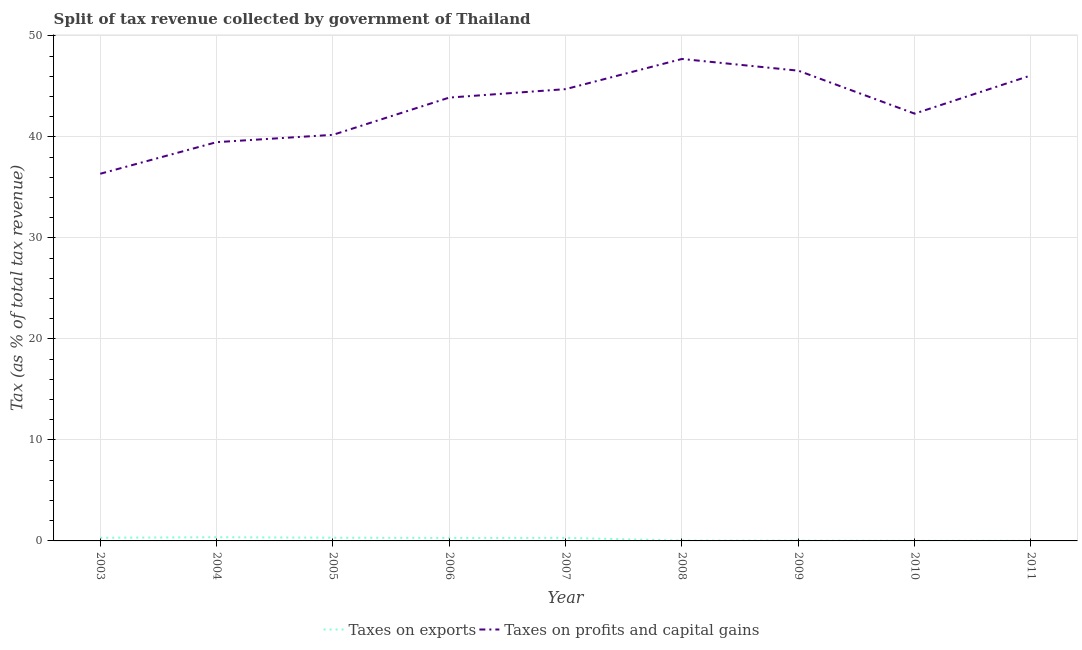Is the number of lines equal to the number of legend labels?
Provide a succinct answer. Yes. What is the percentage of revenue obtained from taxes on profits and capital gains in 2008?
Ensure brevity in your answer.  47.72. Across all years, what is the maximum percentage of revenue obtained from taxes on profits and capital gains?
Offer a terse response. 47.72. Across all years, what is the minimum percentage of revenue obtained from taxes on exports?
Offer a terse response. 0.01. In which year was the percentage of revenue obtained from taxes on exports maximum?
Give a very brief answer. 2004. In which year was the percentage of revenue obtained from taxes on profits and capital gains minimum?
Provide a succinct answer. 2003. What is the total percentage of revenue obtained from taxes on profits and capital gains in the graph?
Your response must be concise. 387.38. What is the difference between the percentage of revenue obtained from taxes on profits and capital gains in 2007 and that in 2010?
Ensure brevity in your answer.  2.43. What is the difference between the percentage of revenue obtained from taxes on exports in 2006 and the percentage of revenue obtained from taxes on profits and capital gains in 2011?
Provide a succinct answer. -45.8. What is the average percentage of revenue obtained from taxes on exports per year?
Your answer should be very brief. 0.19. In the year 2006, what is the difference between the percentage of revenue obtained from taxes on exports and percentage of revenue obtained from taxes on profits and capital gains?
Keep it short and to the point. -43.6. In how many years, is the percentage of revenue obtained from taxes on exports greater than 30 %?
Offer a very short reply. 0. What is the ratio of the percentage of revenue obtained from taxes on profits and capital gains in 2005 to that in 2008?
Offer a very short reply. 0.84. Is the percentage of revenue obtained from taxes on profits and capital gains in 2006 less than that in 2009?
Your response must be concise. Yes. Is the difference between the percentage of revenue obtained from taxes on profits and capital gains in 2006 and 2008 greater than the difference between the percentage of revenue obtained from taxes on exports in 2006 and 2008?
Provide a short and direct response. No. What is the difference between the highest and the second highest percentage of revenue obtained from taxes on exports?
Make the answer very short. 0.05. What is the difference between the highest and the lowest percentage of revenue obtained from taxes on profits and capital gains?
Provide a succinct answer. 11.37. Is the sum of the percentage of revenue obtained from taxes on exports in 2004 and 2005 greater than the maximum percentage of revenue obtained from taxes on profits and capital gains across all years?
Ensure brevity in your answer.  No. Is the percentage of revenue obtained from taxes on exports strictly less than the percentage of revenue obtained from taxes on profits and capital gains over the years?
Keep it short and to the point. Yes. How many lines are there?
Make the answer very short. 2. How many years are there in the graph?
Provide a short and direct response. 9. What is the difference between two consecutive major ticks on the Y-axis?
Make the answer very short. 10. Does the graph contain any zero values?
Make the answer very short. No. Does the graph contain grids?
Offer a terse response. Yes. Where does the legend appear in the graph?
Keep it short and to the point. Bottom center. What is the title of the graph?
Your response must be concise. Split of tax revenue collected by government of Thailand. Does "DAC donors" appear as one of the legend labels in the graph?
Offer a very short reply. No. What is the label or title of the X-axis?
Your response must be concise. Year. What is the label or title of the Y-axis?
Make the answer very short. Tax (as % of total tax revenue). What is the Tax (as % of total tax revenue) of Taxes on exports in 2003?
Keep it short and to the point. 0.31. What is the Tax (as % of total tax revenue) of Taxes on profits and capital gains in 2003?
Make the answer very short. 36.36. What is the Tax (as % of total tax revenue) of Taxes on exports in 2004?
Ensure brevity in your answer.  0.37. What is the Tax (as % of total tax revenue) in Taxes on profits and capital gains in 2004?
Provide a short and direct response. 39.49. What is the Tax (as % of total tax revenue) in Taxes on exports in 2005?
Provide a short and direct response. 0.32. What is the Tax (as % of total tax revenue) of Taxes on profits and capital gains in 2005?
Keep it short and to the point. 40.21. What is the Tax (as % of total tax revenue) in Taxes on exports in 2006?
Offer a very short reply. 0.3. What is the Tax (as % of total tax revenue) in Taxes on profits and capital gains in 2006?
Your answer should be compact. 43.9. What is the Tax (as % of total tax revenue) in Taxes on exports in 2007?
Provide a succinct answer. 0.3. What is the Tax (as % of total tax revenue) in Taxes on profits and capital gains in 2007?
Your answer should be very brief. 44.74. What is the Tax (as % of total tax revenue) of Taxes on exports in 2008?
Ensure brevity in your answer.  0.03. What is the Tax (as % of total tax revenue) in Taxes on profits and capital gains in 2008?
Offer a terse response. 47.72. What is the Tax (as % of total tax revenue) of Taxes on exports in 2009?
Provide a succinct answer. 0.03. What is the Tax (as % of total tax revenue) of Taxes on profits and capital gains in 2009?
Offer a terse response. 46.57. What is the Tax (as % of total tax revenue) in Taxes on exports in 2010?
Ensure brevity in your answer.  0.01. What is the Tax (as % of total tax revenue) of Taxes on profits and capital gains in 2010?
Provide a short and direct response. 42.31. What is the Tax (as % of total tax revenue) in Taxes on exports in 2011?
Make the answer very short. 0.01. What is the Tax (as % of total tax revenue) of Taxes on profits and capital gains in 2011?
Provide a succinct answer. 46.09. Across all years, what is the maximum Tax (as % of total tax revenue) of Taxes on exports?
Give a very brief answer. 0.37. Across all years, what is the maximum Tax (as % of total tax revenue) in Taxes on profits and capital gains?
Provide a succinct answer. 47.72. Across all years, what is the minimum Tax (as % of total tax revenue) in Taxes on exports?
Offer a terse response. 0.01. Across all years, what is the minimum Tax (as % of total tax revenue) of Taxes on profits and capital gains?
Give a very brief answer. 36.36. What is the total Tax (as % of total tax revenue) of Taxes on exports in the graph?
Provide a succinct answer. 1.68. What is the total Tax (as % of total tax revenue) in Taxes on profits and capital gains in the graph?
Make the answer very short. 387.38. What is the difference between the Tax (as % of total tax revenue) of Taxes on exports in 2003 and that in 2004?
Offer a very short reply. -0.05. What is the difference between the Tax (as % of total tax revenue) in Taxes on profits and capital gains in 2003 and that in 2004?
Offer a terse response. -3.13. What is the difference between the Tax (as % of total tax revenue) in Taxes on exports in 2003 and that in 2005?
Provide a short and direct response. -0. What is the difference between the Tax (as % of total tax revenue) in Taxes on profits and capital gains in 2003 and that in 2005?
Offer a very short reply. -3.86. What is the difference between the Tax (as % of total tax revenue) in Taxes on exports in 2003 and that in 2006?
Give a very brief answer. 0.02. What is the difference between the Tax (as % of total tax revenue) of Taxes on profits and capital gains in 2003 and that in 2006?
Provide a short and direct response. -7.54. What is the difference between the Tax (as % of total tax revenue) of Taxes on exports in 2003 and that in 2007?
Your answer should be compact. 0.01. What is the difference between the Tax (as % of total tax revenue) of Taxes on profits and capital gains in 2003 and that in 2007?
Keep it short and to the point. -8.38. What is the difference between the Tax (as % of total tax revenue) in Taxes on exports in 2003 and that in 2008?
Provide a short and direct response. 0.28. What is the difference between the Tax (as % of total tax revenue) of Taxes on profits and capital gains in 2003 and that in 2008?
Provide a succinct answer. -11.37. What is the difference between the Tax (as % of total tax revenue) of Taxes on exports in 2003 and that in 2009?
Provide a succinct answer. 0.28. What is the difference between the Tax (as % of total tax revenue) in Taxes on profits and capital gains in 2003 and that in 2009?
Give a very brief answer. -10.21. What is the difference between the Tax (as % of total tax revenue) of Taxes on exports in 2003 and that in 2010?
Make the answer very short. 0.3. What is the difference between the Tax (as % of total tax revenue) of Taxes on profits and capital gains in 2003 and that in 2010?
Provide a succinct answer. -5.95. What is the difference between the Tax (as % of total tax revenue) in Taxes on exports in 2003 and that in 2011?
Your response must be concise. 0.3. What is the difference between the Tax (as % of total tax revenue) of Taxes on profits and capital gains in 2003 and that in 2011?
Provide a succinct answer. -9.74. What is the difference between the Tax (as % of total tax revenue) in Taxes on exports in 2004 and that in 2005?
Give a very brief answer. 0.05. What is the difference between the Tax (as % of total tax revenue) of Taxes on profits and capital gains in 2004 and that in 2005?
Your answer should be compact. -0.73. What is the difference between the Tax (as % of total tax revenue) in Taxes on exports in 2004 and that in 2006?
Give a very brief answer. 0.07. What is the difference between the Tax (as % of total tax revenue) of Taxes on profits and capital gains in 2004 and that in 2006?
Your answer should be very brief. -4.41. What is the difference between the Tax (as % of total tax revenue) in Taxes on exports in 2004 and that in 2007?
Give a very brief answer. 0.06. What is the difference between the Tax (as % of total tax revenue) of Taxes on profits and capital gains in 2004 and that in 2007?
Your answer should be very brief. -5.25. What is the difference between the Tax (as % of total tax revenue) of Taxes on exports in 2004 and that in 2008?
Provide a succinct answer. 0.33. What is the difference between the Tax (as % of total tax revenue) in Taxes on profits and capital gains in 2004 and that in 2008?
Ensure brevity in your answer.  -8.24. What is the difference between the Tax (as % of total tax revenue) in Taxes on exports in 2004 and that in 2009?
Keep it short and to the point. 0.34. What is the difference between the Tax (as % of total tax revenue) of Taxes on profits and capital gains in 2004 and that in 2009?
Ensure brevity in your answer.  -7.08. What is the difference between the Tax (as % of total tax revenue) in Taxes on exports in 2004 and that in 2010?
Your answer should be compact. 0.36. What is the difference between the Tax (as % of total tax revenue) of Taxes on profits and capital gains in 2004 and that in 2010?
Give a very brief answer. -2.82. What is the difference between the Tax (as % of total tax revenue) in Taxes on exports in 2004 and that in 2011?
Your answer should be compact. 0.35. What is the difference between the Tax (as % of total tax revenue) in Taxes on profits and capital gains in 2004 and that in 2011?
Offer a very short reply. -6.61. What is the difference between the Tax (as % of total tax revenue) of Taxes on exports in 2005 and that in 2006?
Your response must be concise. 0.02. What is the difference between the Tax (as % of total tax revenue) of Taxes on profits and capital gains in 2005 and that in 2006?
Make the answer very short. -3.69. What is the difference between the Tax (as % of total tax revenue) of Taxes on exports in 2005 and that in 2007?
Provide a short and direct response. 0.01. What is the difference between the Tax (as % of total tax revenue) of Taxes on profits and capital gains in 2005 and that in 2007?
Keep it short and to the point. -4.53. What is the difference between the Tax (as % of total tax revenue) of Taxes on exports in 2005 and that in 2008?
Your response must be concise. 0.28. What is the difference between the Tax (as % of total tax revenue) in Taxes on profits and capital gains in 2005 and that in 2008?
Your answer should be very brief. -7.51. What is the difference between the Tax (as % of total tax revenue) in Taxes on exports in 2005 and that in 2009?
Make the answer very short. 0.29. What is the difference between the Tax (as % of total tax revenue) of Taxes on profits and capital gains in 2005 and that in 2009?
Give a very brief answer. -6.35. What is the difference between the Tax (as % of total tax revenue) of Taxes on exports in 2005 and that in 2010?
Your answer should be compact. 0.31. What is the difference between the Tax (as % of total tax revenue) in Taxes on profits and capital gains in 2005 and that in 2010?
Keep it short and to the point. -2.1. What is the difference between the Tax (as % of total tax revenue) in Taxes on exports in 2005 and that in 2011?
Offer a very short reply. 0.3. What is the difference between the Tax (as % of total tax revenue) of Taxes on profits and capital gains in 2005 and that in 2011?
Your response must be concise. -5.88. What is the difference between the Tax (as % of total tax revenue) of Taxes on exports in 2006 and that in 2007?
Provide a short and direct response. -0.01. What is the difference between the Tax (as % of total tax revenue) of Taxes on profits and capital gains in 2006 and that in 2007?
Give a very brief answer. -0.84. What is the difference between the Tax (as % of total tax revenue) in Taxes on exports in 2006 and that in 2008?
Make the answer very short. 0.26. What is the difference between the Tax (as % of total tax revenue) of Taxes on profits and capital gains in 2006 and that in 2008?
Offer a very short reply. -3.82. What is the difference between the Tax (as % of total tax revenue) of Taxes on exports in 2006 and that in 2009?
Keep it short and to the point. 0.27. What is the difference between the Tax (as % of total tax revenue) of Taxes on profits and capital gains in 2006 and that in 2009?
Your answer should be compact. -2.67. What is the difference between the Tax (as % of total tax revenue) of Taxes on exports in 2006 and that in 2010?
Offer a very short reply. 0.28. What is the difference between the Tax (as % of total tax revenue) of Taxes on profits and capital gains in 2006 and that in 2010?
Ensure brevity in your answer.  1.59. What is the difference between the Tax (as % of total tax revenue) in Taxes on exports in 2006 and that in 2011?
Offer a very short reply. 0.28. What is the difference between the Tax (as % of total tax revenue) of Taxes on profits and capital gains in 2006 and that in 2011?
Keep it short and to the point. -2.19. What is the difference between the Tax (as % of total tax revenue) of Taxes on exports in 2007 and that in 2008?
Your answer should be very brief. 0.27. What is the difference between the Tax (as % of total tax revenue) in Taxes on profits and capital gains in 2007 and that in 2008?
Give a very brief answer. -2.99. What is the difference between the Tax (as % of total tax revenue) of Taxes on exports in 2007 and that in 2009?
Ensure brevity in your answer.  0.27. What is the difference between the Tax (as % of total tax revenue) in Taxes on profits and capital gains in 2007 and that in 2009?
Ensure brevity in your answer.  -1.83. What is the difference between the Tax (as % of total tax revenue) in Taxes on exports in 2007 and that in 2010?
Ensure brevity in your answer.  0.29. What is the difference between the Tax (as % of total tax revenue) of Taxes on profits and capital gains in 2007 and that in 2010?
Your response must be concise. 2.43. What is the difference between the Tax (as % of total tax revenue) in Taxes on exports in 2007 and that in 2011?
Your response must be concise. 0.29. What is the difference between the Tax (as % of total tax revenue) of Taxes on profits and capital gains in 2007 and that in 2011?
Your answer should be compact. -1.36. What is the difference between the Tax (as % of total tax revenue) of Taxes on exports in 2008 and that in 2009?
Make the answer very short. 0. What is the difference between the Tax (as % of total tax revenue) of Taxes on profits and capital gains in 2008 and that in 2009?
Your answer should be very brief. 1.16. What is the difference between the Tax (as % of total tax revenue) of Taxes on exports in 2008 and that in 2010?
Your answer should be compact. 0.02. What is the difference between the Tax (as % of total tax revenue) in Taxes on profits and capital gains in 2008 and that in 2010?
Provide a succinct answer. 5.41. What is the difference between the Tax (as % of total tax revenue) in Taxes on exports in 2008 and that in 2011?
Your answer should be very brief. 0.02. What is the difference between the Tax (as % of total tax revenue) in Taxes on profits and capital gains in 2008 and that in 2011?
Provide a short and direct response. 1.63. What is the difference between the Tax (as % of total tax revenue) in Taxes on exports in 2009 and that in 2010?
Offer a terse response. 0.02. What is the difference between the Tax (as % of total tax revenue) in Taxes on profits and capital gains in 2009 and that in 2010?
Ensure brevity in your answer.  4.26. What is the difference between the Tax (as % of total tax revenue) in Taxes on exports in 2009 and that in 2011?
Give a very brief answer. 0.02. What is the difference between the Tax (as % of total tax revenue) in Taxes on profits and capital gains in 2009 and that in 2011?
Give a very brief answer. 0.47. What is the difference between the Tax (as % of total tax revenue) of Taxes on exports in 2010 and that in 2011?
Keep it short and to the point. -0. What is the difference between the Tax (as % of total tax revenue) in Taxes on profits and capital gains in 2010 and that in 2011?
Your answer should be very brief. -3.78. What is the difference between the Tax (as % of total tax revenue) in Taxes on exports in 2003 and the Tax (as % of total tax revenue) in Taxes on profits and capital gains in 2004?
Ensure brevity in your answer.  -39.17. What is the difference between the Tax (as % of total tax revenue) in Taxes on exports in 2003 and the Tax (as % of total tax revenue) in Taxes on profits and capital gains in 2005?
Give a very brief answer. -39.9. What is the difference between the Tax (as % of total tax revenue) in Taxes on exports in 2003 and the Tax (as % of total tax revenue) in Taxes on profits and capital gains in 2006?
Your answer should be compact. -43.59. What is the difference between the Tax (as % of total tax revenue) in Taxes on exports in 2003 and the Tax (as % of total tax revenue) in Taxes on profits and capital gains in 2007?
Offer a very short reply. -44.42. What is the difference between the Tax (as % of total tax revenue) of Taxes on exports in 2003 and the Tax (as % of total tax revenue) of Taxes on profits and capital gains in 2008?
Offer a very short reply. -47.41. What is the difference between the Tax (as % of total tax revenue) in Taxes on exports in 2003 and the Tax (as % of total tax revenue) in Taxes on profits and capital gains in 2009?
Ensure brevity in your answer.  -46.25. What is the difference between the Tax (as % of total tax revenue) of Taxes on exports in 2003 and the Tax (as % of total tax revenue) of Taxes on profits and capital gains in 2010?
Provide a short and direct response. -42. What is the difference between the Tax (as % of total tax revenue) in Taxes on exports in 2003 and the Tax (as % of total tax revenue) in Taxes on profits and capital gains in 2011?
Offer a terse response. -45.78. What is the difference between the Tax (as % of total tax revenue) in Taxes on exports in 2004 and the Tax (as % of total tax revenue) in Taxes on profits and capital gains in 2005?
Make the answer very short. -39.85. What is the difference between the Tax (as % of total tax revenue) of Taxes on exports in 2004 and the Tax (as % of total tax revenue) of Taxes on profits and capital gains in 2006?
Give a very brief answer. -43.53. What is the difference between the Tax (as % of total tax revenue) in Taxes on exports in 2004 and the Tax (as % of total tax revenue) in Taxes on profits and capital gains in 2007?
Give a very brief answer. -44.37. What is the difference between the Tax (as % of total tax revenue) of Taxes on exports in 2004 and the Tax (as % of total tax revenue) of Taxes on profits and capital gains in 2008?
Your answer should be very brief. -47.36. What is the difference between the Tax (as % of total tax revenue) in Taxes on exports in 2004 and the Tax (as % of total tax revenue) in Taxes on profits and capital gains in 2009?
Your answer should be compact. -46.2. What is the difference between the Tax (as % of total tax revenue) in Taxes on exports in 2004 and the Tax (as % of total tax revenue) in Taxes on profits and capital gains in 2010?
Provide a short and direct response. -41.94. What is the difference between the Tax (as % of total tax revenue) of Taxes on exports in 2004 and the Tax (as % of total tax revenue) of Taxes on profits and capital gains in 2011?
Offer a terse response. -45.73. What is the difference between the Tax (as % of total tax revenue) of Taxes on exports in 2005 and the Tax (as % of total tax revenue) of Taxes on profits and capital gains in 2006?
Offer a very short reply. -43.58. What is the difference between the Tax (as % of total tax revenue) in Taxes on exports in 2005 and the Tax (as % of total tax revenue) in Taxes on profits and capital gains in 2007?
Make the answer very short. -44.42. What is the difference between the Tax (as % of total tax revenue) in Taxes on exports in 2005 and the Tax (as % of total tax revenue) in Taxes on profits and capital gains in 2008?
Ensure brevity in your answer.  -47.41. What is the difference between the Tax (as % of total tax revenue) of Taxes on exports in 2005 and the Tax (as % of total tax revenue) of Taxes on profits and capital gains in 2009?
Make the answer very short. -46.25. What is the difference between the Tax (as % of total tax revenue) in Taxes on exports in 2005 and the Tax (as % of total tax revenue) in Taxes on profits and capital gains in 2010?
Ensure brevity in your answer.  -41.99. What is the difference between the Tax (as % of total tax revenue) of Taxes on exports in 2005 and the Tax (as % of total tax revenue) of Taxes on profits and capital gains in 2011?
Your response must be concise. -45.78. What is the difference between the Tax (as % of total tax revenue) in Taxes on exports in 2006 and the Tax (as % of total tax revenue) in Taxes on profits and capital gains in 2007?
Provide a short and direct response. -44.44. What is the difference between the Tax (as % of total tax revenue) of Taxes on exports in 2006 and the Tax (as % of total tax revenue) of Taxes on profits and capital gains in 2008?
Your answer should be very brief. -47.43. What is the difference between the Tax (as % of total tax revenue) of Taxes on exports in 2006 and the Tax (as % of total tax revenue) of Taxes on profits and capital gains in 2009?
Keep it short and to the point. -46.27. What is the difference between the Tax (as % of total tax revenue) in Taxes on exports in 2006 and the Tax (as % of total tax revenue) in Taxes on profits and capital gains in 2010?
Provide a succinct answer. -42.01. What is the difference between the Tax (as % of total tax revenue) in Taxes on exports in 2006 and the Tax (as % of total tax revenue) in Taxes on profits and capital gains in 2011?
Your answer should be very brief. -45.8. What is the difference between the Tax (as % of total tax revenue) in Taxes on exports in 2007 and the Tax (as % of total tax revenue) in Taxes on profits and capital gains in 2008?
Offer a terse response. -47.42. What is the difference between the Tax (as % of total tax revenue) in Taxes on exports in 2007 and the Tax (as % of total tax revenue) in Taxes on profits and capital gains in 2009?
Your response must be concise. -46.26. What is the difference between the Tax (as % of total tax revenue) of Taxes on exports in 2007 and the Tax (as % of total tax revenue) of Taxes on profits and capital gains in 2010?
Your answer should be very brief. -42.01. What is the difference between the Tax (as % of total tax revenue) of Taxes on exports in 2007 and the Tax (as % of total tax revenue) of Taxes on profits and capital gains in 2011?
Your response must be concise. -45.79. What is the difference between the Tax (as % of total tax revenue) of Taxes on exports in 2008 and the Tax (as % of total tax revenue) of Taxes on profits and capital gains in 2009?
Offer a very short reply. -46.53. What is the difference between the Tax (as % of total tax revenue) of Taxes on exports in 2008 and the Tax (as % of total tax revenue) of Taxes on profits and capital gains in 2010?
Provide a succinct answer. -42.28. What is the difference between the Tax (as % of total tax revenue) of Taxes on exports in 2008 and the Tax (as % of total tax revenue) of Taxes on profits and capital gains in 2011?
Your answer should be compact. -46.06. What is the difference between the Tax (as % of total tax revenue) in Taxes on exports in 2009 and the Tax (as % of total tax revenue) in Taxes on profits and capital gains in 2010?
Ensure brevity in your answer.  -42.28. What is the difference between the Tax (as % of total tax revenue) of Taxes on exports in 2009 and the Tax (as % of total tax revenue) of Taxes on profits and capital gains in 2011?
Provide a short and direct response. -46.06. What is the difference between the Tax (as % of total tax revenue) in Taxes on exports in 2010 and the Tax (as % of total tax revenue) in Taxes on profits and capital gains in 2011?
Offer a very short reply. -46.08. What is the average Tax (as % of total tax revenue) in Taxes on exports per year?
Offer a very short reply. 0.19. What is the average Tax (as % of total tax revenue) of Taxes on profits and capital gains per year?
Your answer should be compact. 43.04. In the year 2003, what is the difference between the Tax (as % of total tax revenue) of Taxes on exports and Tax (as % of total tax revenue) of Taxes on profits and capital gains?
Offer a terse response. -36.04. In the year 2004, what is the difference between the Tax (as % of total tax revenue) in Taxes on exports and Tax (as % of total tax revenue) in Taxes on profits and capital gains?
Your answer should be very brief. -39.12. In the year 2005, what is the difference between the Tax (as % of total tax revenue) in Taxes on exports and Tax (as % of total tax revenue) in Taxes on profits and capital gains?
Your answer should be compact. -39.89. In the year 2006, what is the difference between the Tax (as % of total tax revenue) of Taxes on exports and Tax (as % of total tax revenue) of Taxes on profits and capital gains?
Provide a succinct answer. -43.6. In the year 2007, what is the difference between the Tax (as % of total tax revenue) in Taxes on exports and Tax (as % of total tax revenue) in Taxes on profits and capital gains?
Your answer should be very brief. -44.43. In the year 2008, what is the difference between the Tax (as % of total tax revenue) in Taxes on exports and Tax (as % of total tax revenue) in Taxes on profits and capital gains?
Ensure brevity in your answer.  -47.69. In the year 2009, what is the difference between the Tax (as % of total tax revenue) in Taxes on exports and Tax (as % of total tax revenue) in Taxes on profits and capital gains?
Keep it short and to the point. -46.54. In the year 2010, what is the difference between the Tax (as % of total tax revenue) of Taxes on exports and Tax (as % of total tax revenue) of Taxes on profits and capital gains?
Your answer should be compact. -42.3. In the year 2011, what is the difference between the Tax (as % of total tax revenue) in Taxes on exports and Tax (as % of total tax revenue) in Taxes on profits and capital gains?
Your answer should be compact. -46.08. What is the ratio of the Tax (as % of total tax revenue) in Taxes on exports in 2003 to that in 2004?
Ensure brevity in your answer.  0.85. What is the ratio of the Tax (as % of total tax revenue) of Taxes on profits and capital gains in 2003 to that in 2004?
Give a very brief answer. 0.92. What is the ratio of the Tax (as % of total tax revenue) of Taxes on exports in 2003 to that in 2005?
Ensure brevity in your answer.  0.99. What is the ratio of the Tax (as % of total tax revenue) in Taxes on profits and capital gains in 2003 to that in 2005?
Provide a short and direct response. 0.9. What is the ratio of the Tax (as % of total tax revenue) of Taxes on exports in 2003 to that in 2006?
Keep it short and to the point. 1.06. What is the ratio of the Tax (as % of total tax revenue) of Taxes on profits and capital gains in 2003 to that in 2006?
Offer a very short reply. 0.83. What is the ratio of the Tax (as % of total tax revenue) in Taxes on exports in 2003 to that in 2007?
Offer a very short reply. 1.03. What is the ratio of the Tax (as % of total tax revenue) in Taxes on profits and capital gains in 2003 to that in 2007?
Your answer should be compact. 0.81. What is the ratio of the Tax (as % of total tax revenue) of Taxes on exports in 2003 to that in 2008?
Provide a short and direct response. 9.35. What is the ratio of the Tax (as % of total tax revenue) of Taxes on profits and capital gains in 2003 to that in 2008?
Provide a short and direct response. 0.76. What is the ratio of the Tax (as % of total tax revenue) of Taxes on exports in 2003 to that in 2009?
Your answer should be very brief. 10.73. What is the ratio of the Tax (as % of total tax revenue) in Taxes on profits and capital gains in 2003 to that in 2009?
Make the answer very short. 0.78. What is the ratio of the Tax (as % of total tax revenue) in Taxes on exports in 2003 to that in 2010?
Ensure brevity in your answer.  30.17. What is the ratio of the Tax (as % of total tax revenue) of Taxes on profits and capital gains in 2003 to that in 2010?
Give a very brief answer. 0.86. What is the ratio of the Tax (as % of total tax revenue) in Taxes on exports in 2003 to that in 2011?
Your response must be concise. 24.25. What is the ratio of the Tax (as % of total tax revenue) of Taxes on profits and capital gains in 2003 to that in 2011?
Provide a short and direct response. 0.79. What is the ratio of the Tax (as % of total tax revenue) in Taxes on exports in 2004 to that in 2005?
Provide a short and direct response. 1.15. What is the ratio of the Tax (as % of total tax revenue) in Taxes on exports in 2004 to that in 2006?
Give a very brief answer. 1.24. What is the ratio of the Tax (as % of total tax revenue) of Taxes on profits and capital gains in 2004 to that in 2006?
Keep it short and to the point. 0.9. What is the ratio of the Tax (as % of total tax revenue) in Taxes on exports in 2004 to that in 2007?
Ensure brevity in your answer.  1.21. What is the ratio of the Tax (as % of total tax revenue) of Taxes on profits and capital gains in 2004 to that in 2007?
Give a very brief answer. 0.88. What is the ratio of the Tax (as % of total tax revenue) in Taxes on exports in 2004 to that in 2008?
Offer a terse response. 10.95. What is the ratio of the Tax (as % of total tax revenue) of Taxes on profits and capital gains in 2004 to that in 2008?
Offer a terse response. 0.83. What is the ratio of the Tax (as % of total tax revenue) of Taxes on exports in 2004 to that in 2009?
Make the answer very short. 12.56. What is the ratio of the Tax (as % of total tax revenue) of Taxes on profits and capital gains in 2004 to that in 2009?
Offer a very short reply. 0.85. What is the ratio of the Tax (as % of total tax revenue) of Taxes on exports in 2004 to that in 2010?
Give a very brief answer. 35.32. What is the ratio of the Tax (as % of total tax revenue) in Taxes on exports in 2004 to that in 2011?
Make the answer very short. 28.39. What is the ratio of the Tax (as % of total tax revenue) in Taxes on profits and capital gains in 2004 to that in 2011?
Keep it short and to the point. 0.86. What is the ratio of the Tax (as % of total tax revenue) of Taxes on exports in 2005 to that in 2006?
Ensure brevity in your answer.  1.08. What is the ratio of the Tax (as % of total tax revenue) in Taxes on profits and capital gains in 2005 to that in 2006?
Ensure brevity in your answer.  0.92. What is the ratio of the Tax (as % of total tax revenue) of Taxes on exports in 2005 to that in 2007?
Offer a terse response. 1.05. What is the ratio of the Tax (as % of total tax revenue) in Taxes on profits and capital gains in 2005 to that in 2007?
Your answer should be very brief. 0.9. What is the ratio of the Tax (as % of total tax revenue) of Taxes on exports in 2005 to that in 2008?
Provide a succinct answer. 9.49. What is the ratio of the Tax (as % of total tax revenue) in Taxes on profits and capital gains in 2005 to that in 2008?
Your answer should be very brief. 0.84. What is the ratio of the Tax (as % of total tax revenue) of Taxes on exports in 2005 to that in 2009?
Offer a terse response. 10.89. What is the ratio of the Tax (as % of total tax revenue) of Taxes on profits and capital gains in 2005 to that in 2009?
Ensure brevity in your answer.  0.86. What is the ratio of the Tax (as % of total tax revenue) of Taxes on exports in 2005 to that in 2010?
Provide a succinct answer. 30.63. What is the ratio of the Tax (as % of total tax revenue) in Taxes on profits and capital gains in 2005 to that in 2010?
Your answer should be very brief. 0.95. What is the ratio of the Tax (as % of total tax revenue) of Taxes on exports in 2005 to that in 2011?
Your response must be concise. 24.62. What is the ratio of the Tax (as % of total tax revenue) in Taxes on profits and capital gains in 2005 to that in 2011?
Make the answer very short. 0.87. What is the ratio of the Tax (as % of total tax revenue) of Taxes on exports in 2006 to that in 2007?
Provide a succinct answer. 0.97. What is the ratio of the Tax (as % of total tax revenue) of Taxes on profits and capital gains in 2006 to that in 2007?
Your answer should be compact. 0.98. What is the ratio of the Tax (as % of total tax revenue) in Taxes on exports in 2006 to that in 2008?
Give a very brief answer. 8.82. What is the ratio of the Tax (as % of total tax revenue) in Taxes on profits and capital gains in 2006 to that in 2008?
Your response must be concise. 0.92. What is the ratio of the Tax (as % of total tax revenue) in Taxes on exports in 2006 to that in 2009?
Offer a very short reply. 10.12. What is the ratio of the Tax (as % of total tax revenue) of Taxes on profits and capital gains in 2006 to that in 2009?
Provide a short and direct response. 0.94. What is the ratio of the Tax (as % of total tax revenue) of Taxes on exports in 2006 to that in 2010?
Give a very brief answer. 28.46. What is the ratio of the Tax (as % of total tax revenue) of Taxes on profits and capital gains in 2006 to that in 2010?
Keep it short and to the point. 1.04. What is the ratio of the Tax (as % of total tax revenue) in Taxes on exports in 2006 to that in 2011?
Offer a very short reply. 22.87. What is the ratio of the Tax (as % of total tax revenue) in Taxes on profits and capital gains in 2006 to that in 2011?
Offer a very short reply. 0.95. What is the ratio of the Tax (as % of total tax revenue) of Taxes on exports in 2007 to that in 2008?
Your answer should be compact. 9.05. What is the ratio of the Tax (as % of total tax revenue) of Taxes on profits and capital gains in 2007 to that in 2008?
Give a very brief answer. 0.94. What is the ratio of the Tax (as % of total tax revenue) in Taxes on exports in 2007 to that in 2009?
Offer a very short reply. 10.38. What is the ratio of the Tax (as % of total tax revenue) in Taxes on profits and capital gains in 2007 to that in 2009?
Offer a terse response. 0.96. What is the ratio of the Tax (as % of total tax revenue) of Taxes on exports in 2007 to that in 2010?
Make the answer very short. 29.19. What is the ratio of the Tax (as % of total tax revenue) in Taxes on profits and capital gains in 2007 to that in 2010?
Your answer should be compact. 1.06. What is the ratio of the Tax (as % of total tax revenue) of Taxes on exports in 2007 to that in 2011?
Keep it short and to the point. 23.46. What is the ratio of the Tax (as % of total tax revenue) in Taxes on profits and capital gains in 2007 to that in 2011?
Offer a terse response. 0.97. What is the ratio of the Tax (as % of total tax revenue) in Taxes on exports in 2008 to that in 2009?
Give a very brief answer. 1.15. What is the ratio of the Tax (as % of total tax revenue) of Taxes on profits and capital gains in 2008 to that in 2009?
Offer a very short reply. 1.02. What is the ratio of the Tax (as % of total tax revenue) of Taxes on exports in 2008 to that in 2010?
Your answer should be compact. 3.23. What is the ratio of the Tax (as % of total tax revenue) of Taxes on profits and capital gains in 2008 to that in 2010?
Your answer should be compact. 1.13. What is the ratio of the Tax (as % of total tax revenue) of Taxes on exports in 2008 to that in 2011?
Offer a terse response. 2.59. What is the ratio of the Tax (as % of total tax revenue) of Taxes on profits and capital gains in 2008 to that in 2011?
Ensure brevity in your answer.  1.04. What is the ratio of the Tax (as % of total tax revenue) of Taxes on exports in 2009 to that in 2010?
Your answer should be compact. 2.81. What is the ratio of the Tax (as % of total tax revenue) of Taxes on profits and capital gains in 2009 to that in 2010?
Ensure brevity in your answer.  1.1. What is the ratio of the Tax (as % of total tax revenue) in Taxes on exports in 2009 to that in 2011?
Offer a very short reply. 2.26. What is the ratio of the Tax (as % of total tax revenue) of Taxes on profits and capital gains in 2009 to that in 2011?
Give a very brief answer. 1.01. What is the ratio of the Tax (as % of total tax revenue) of Taxes on exports in 2010 to that in 2011?
Your answer should be compact. 0.8. What is the ratio of the Tax (as % of total tax revenue) of Taxes on profits and capital gains in 2010 to that in 2011?
Your answer should be very brief. 0.92. What is the difference between the highest and the second highest Tax (as % of total tax revenue) in Taxes on exports?
Give a very brief answer. 0.05. What is the difference between the highest and the second highest Tax (as % of total tax revenue) of Taxes on profits and capital gains?
Ensure brevity in your answer.  1.16. What is the difference between the highest and the lowest Tax (as % of total tax revenue) in Taxes on exports?
Ensure brevity in your answer.  0.36. What is the difference between the highest and the lowest Tax (as % of total tax revenue) in Taxes on profits and capital gains?
Your response must be concise. 11.37. 